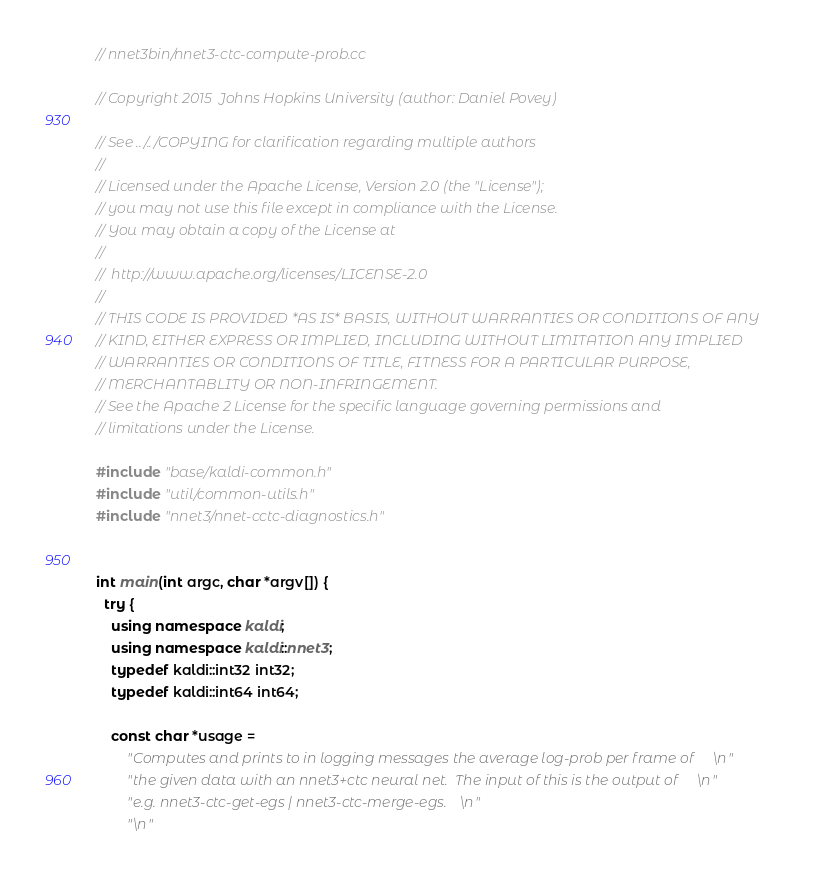Convert code to text. <code><loc_0><loc_0><loc_500><loc_500><_C++_>// nnet3bin/nnet3-ctc-compute-prob.cc

// Copyright 2015  Johns Hopkins University (author: Daniel Povey)

// See ../../COPYING for clarification regarding multiple authors
//
// Licensed under the Apache License, Version 2.0 (the "License");
// you may not use this file except in compliance with the License.
// You may obtain a copy of the License at
//
//  http://www.apache.org/licenses/LICENSE-2.0
//
// THIS CODE IS PROVIDED *AS IS* BASIS, WITHOUT WARRANTIES OR CONDITIONS OF ANY
// KIND, EITHER EXPRESS OR IMPLIED, INCLUDING WITHOUT LIMITATION ANY IMPLIED
// WARRANTIES OR CONDITIONS OF TITLE, FITNESS FOR A PARTICULAR PURPOSE,
// MERCHANTABLITY OR NON-INFRINGEMENT.
// See the Apache 2 License for the specific language governing permissions and
// limitations under the License.

#include "base/kaldi-common.h"
#include "util/common-utils.h"
#include "nnet3/nnet-cctc-diagnostics.h"


int main(int argc, char *argv[]) {
  try {
    using namespace kaldi;
    using namespace kaldi::nnet3;
    typedef kaldi::int32 int32;
    typedef kaldi::int64 int64;

    const char *usage =
        "Computes and prints to in logging messages the average log-prob per frame of\n"
        "the given data with an nnet3+ctc neural net.  The input of this is the output of\n"
        "e.g. nnet3-ctc-get-egs | nnet3-ctc-merge-egs.\n"
        "\n"</code> 